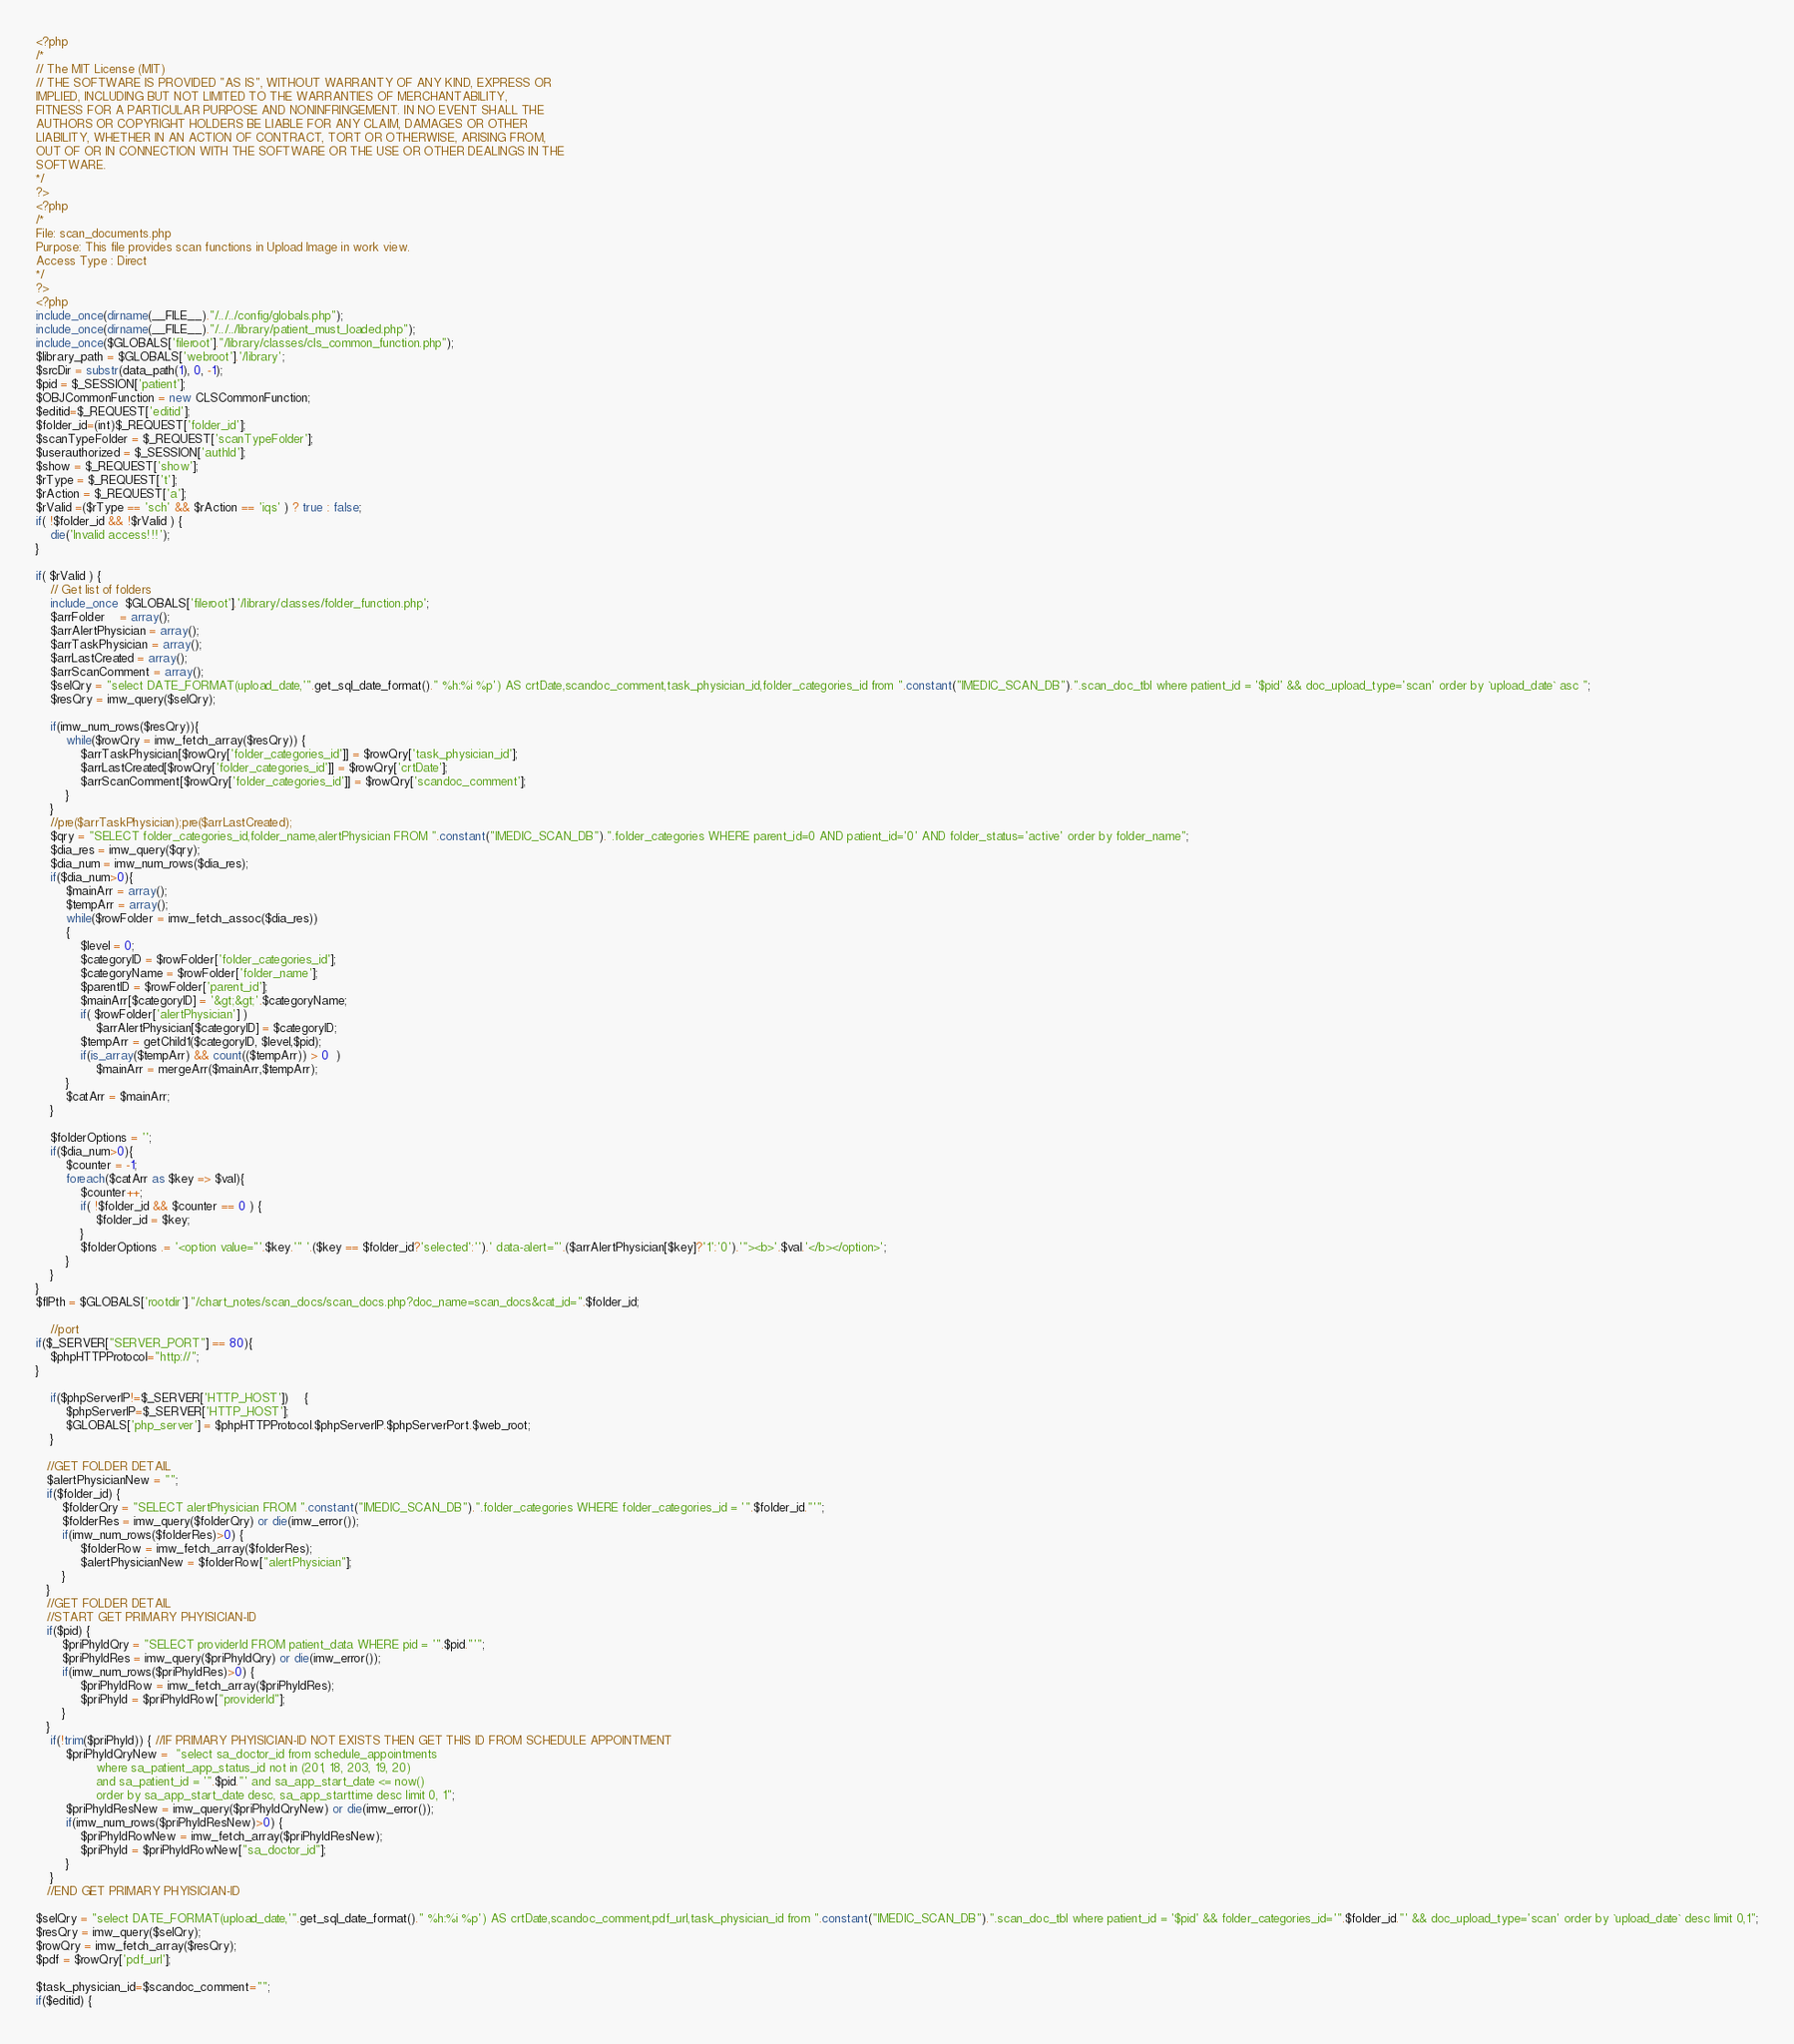Convert code to text. <code><loc_0><loc_0><loc_500><loc_500><_PHP_><?php
/*
// The MIT License (MIT)
// THE SOFTWARE IS PROVIDED "AS IS", WITHOUT WARRANTY OF ANY KIND, EXPRESS OR
IMPLIED, INCLUDING BUT NOT LIMITED TO THE WARRANTIES OF MERCHANTABILITY,
FITNESS FOR A PARTICULAR PURPOSE AND NONINFRINGEMENT. IN NO EVENT SHALL THE
AUTHORS OR COPYRIGHT HOLDERS BE LIABLE FOR ANY CLAIM, DAMAGES OR OTHER
LIABILITY, WHETHER IN AN ACTION OF CONTRACT, TORT OR OTHERWISE, ARISING FROM,
OUT OF OR IN CONNECTION WITH THE SOFTWARE OR THE USE OR OTHER DEALINGS IN THE
SOFTWARE.
*/
?>
<?php
/*
File: scan_documents.php
Purpose: This file provides scan functions in Upload Image in work view.
Access Type : Direct
*/
?>
<?php
include_once(dirname(__FILE__)."/../../config/globals.php");
include_once(dirname(__FILE__)."/../../library/patient_must_loaded.php");
include_once($GLOBALS['fileroot']."/library/classes/cls_common_function.php");
$library_path = $GLOBALS['webroot'].'/library';	
$srcDir = substr(data_path(1), 0, -1);
$pid = $_SESSION['patient'];
$OBJCommonFunction = new CLSCommonFunction;	
$editid=$_REQUEST['editid'];
$folder_id=(int)$_REQUEST['folder_id'];
$scanTypeFolder = $_REQUEST['scanTypeFolder'];
$userauthorized = $_SESSION['authId'];
$show = $_REQUEST['show'];
$rType = $_REQUEST['t'];
$rAction = $_REQUEST['a'];
$rValid =($rType == 'sch' && $rAction == 'iqs' ) ? true : false;
if( !$folder_id && !$rValid ) {
    die('Invalid access!!!');
}

if( $rValid ) {
    // Get list of folders 
    include_once  $GLOBALS['fileroot'].'/library/classes/folder_function.php';
    $arrFolder	= array();
    $arrAlertPhysician = array();
    $arrTaskPhysician = array();
    $arrLastCreated = array();
    $arrScanComment = array();
    $selQry = "select DATE_FORMAT(upload_date,'".get_sql_date_format()." %h:%i %p') AS crtDate,scandoc_comment,task_physician_id,folder_categories_id from ".constant("IMEDIC_SCAN_DB").".scan_doc_tbl where patient_id = '$pid' && doc_upload_type='scan' order by `upload_date` asc ";
    $resQry = imw_query($selQry);
    
    if(imw_num_rows($resQry)){
        while($rowQry = imw_fetch_array($resQry)) {
            $arrTaskPhysician[$rowQry['folder_categories_id']] = $rowQry['task_physician_id'];
            $arrLastCreated[$rowQry['folder_categories_id']] = $rowQry['crtDate'];
            $arrScanComment[$rowQry['folder_categories_id']] = $rowQry['scandoc_comment'];
        }
    }
    //pre($arrTaskPhysician);pre($arrLastCreated);
    $qry = "SELECT folder_categories_id,folder_name,alertPhysician FROM ".constant("IMEDIC_SCAN_DB").".folder_categories WHERE parent_id=0 AND patient_id='0' AND folder_status='active' order by folder_name";
    $dia_res = imw_query($qry);
    $dia_num = imw_num_rows($dia_res);
    if($dia_num>0){
        $mainArr = array();
        $tempArr = array();
        while($rowFolder = imw_fetch_assoc($dia_res))
        {
            $level = 0;
            $categoryID = $rowFolder['folder_categories_id'];
            $categoryName = $rowFolder['folder_name'];
            $parentID = $rowFolder['parent_id'];
            $mainArr[$categoryID] = '&gt;&gt;'.$categoryName;
            if( $rowFolder['alertPhysician'] ) 
                $arrAlertPhysician[$categoryID] = $categoryID;
            $tempArr = getChild1($categoryID, $level,$pid);
            if(is_array($tempArr) && count(($tempArr)) > 0  )
                $mainArr = mergeArr($mainArr,$tempArr);
        }
        $catArr = $mainArr;
    }
    
    $folderOptions = '';
    if($dia_num>0){
        $counter = -1;
        foreach($catArr as $key => $val){
            $counter++;
            if( !$folder_id && $counter == 0 ) {
                $folder_id = $key;
            }
            $folderOptions .= '<option value="'.$key.'" '.($key == $folder_id?'selected':'').' data-alert="'.($arrAlertPhysician[$key]?'1':'0').'"><b>'.$val.'</b></option>';
        }
    }
}
$flPth = $GLOBALS['rootdir']."/chart_notes/scan_docs/scan_docs.php?doc_name=scan_docs&cat_id=".$folder_id;

	//port
if($_SERVER["SERVER_PORT"] == 80){
	$phpHTTPProtocol="http://";
}
	
	if($phpServerIP!=$_SERVER['HTTP_HOST'])	{
		$phpServerIP=$_SERVER['HTTP_HOST'];
		$GLOBALS['php_server'] = $phpHTTPProtocol.$phpServerIP.$phpServerPort.$web_root;
    }

   //GET FOLDER DETAIL
   $alertPhysicianNew = "";
   if($folder_id) {
	   $folderQry = "SELECT alertPhysician FROM ".constant("IMEDIC_SCAN_DB").".folder_categories WHERE folder_categories_id = '".$folder_id."'";
	   $folderRes = imw_query($folderQry) or die(imw_error());
	   if(imw_num_rows($folderRes)>0) {
			$folderRow = imw_fetch_array($folderRes);   
			$alertPhysicianNew = $folderRow["alertPhysician"];
	   }
   }
   //GET FOLDER DETAIL
   //START GET PRIMARY PHYISICIAN-ID
   if($pid) {
	   $priPhyIdQry = "SELECT providerId FROM patient_data WHERE pid = '".$pid."'";
	   $priPhyIdRes = imw_query($priPhyIdQry) or die(imw_error());
	   if(imw_num_rows($priPhyIdRes)>0) {
			$priPhyIdRow = imw_fetch_array($priPhyIdRes);   
			$priPhyId = $priPhyIdRow["providerId"];
	   }
   }
	if(!trim($priPhyId)) { //IF PRIMARY PHYISICIAN-ID NOT EXISTS THEN GET THIS ID FROM SCHEDULE APPOINTMENT
		$priPhyIdQryNew =  "select sa_doctor_id from schedule_appointments
				where sa_patient_app_status_id not in (201, 18, 203, 19, 20)
				and sa_patient_id = '".$pid."' and sa_app_start_date <= now()
				order by sa_app_start_date desc, sa_app_starttime desc limit 0, 1"; 
		$priPhyIdResNew = imw_query($priPhyIdQryNew) or die(imw_error());
		if(imw_num_rows($priPhyIdResNew)>0) {
			$priPhyIdRowNew = imw_fetch_array($priPhyIdResNew);   
			$priPhyId = $priPhyIdRowNew["sa_doctor_id"];
		}
	}
   //END GET PRIMARY PHYISICIAN-ID

$selQry = "select DATE_FORMAT(upload_date,'".get_sql_date_format()." %h:%i %p') AS crtDate,scandoc_comment,pdf_url,task_physician_id from ".constant("IMEDIC_SCAN_DB").".scan_doc_tbl where patient_id = '$pid' && folder_categories_id='".$folder_id."' && doc_upload_type='scan' order by `upload_date` desc limit 0,1";
$resQry = imw_query($selQry);
$rowQry = imw_fetch_array($resQry);
$pdf = $rowQry['pdf_url'];

$task_physician_id=$scandoc_comment="";
if($editid) {</code> 